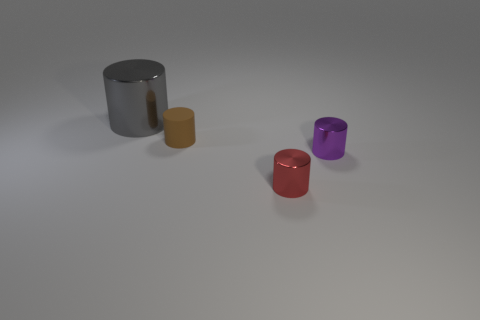Are there any other things that are the same size as the gray shiny thing?
Your answer should be very brief. No. What is the size of the gray metal cylinder?
Make the answer very short. Large. What color is the cylinder that is both in front of the small brown rubber object and behind the tiny red metal object?
Make the answer very short. Purple. Are there more large metallic things than big yellow matte cylinders?
Provide a succinct answer. Yes. How many objects are either red objects or shiny cylinders that are on the right side of the red metal object?
Your response must be concise. 2. Is the purple cylinder the same size as the brown rubber cylinder?
Give a very brief answer. Yes. There is a small brown matte thing; are there any small objects in front of it?
Your response must be concise. Yes. There is a metal thing that is behind the red object and left of the small purple cylinder; what is its size?
Offer a very short reply. Large. How many objects are gray cylinders or large blue rubber balls?
Offer a very short reply. 1. Do the red cylinder and the metal cylinder that is behind the purple thing have the same size?
Provide a succinct answer. No. 